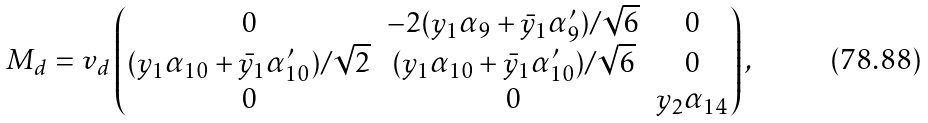Convert formula to latex. <formula><loc_0><loc_0><loc_500><loc_500>M _ { d } = v _ { d } \begin{pmatrix} 0 & - 2 ( y _ { 1 } \alpha _ { 9 } + \bar { y } _ { 1 } \alpha _ { 9 } ^ { \prime } ) / \sqrt { 6 } & 0 \\ ( y _ { 1 } \alpha _ { 1 0 } + \bar { y } _ { 1 } \alpha _ { 1 0 } ^ { \prime } ) / \sqrt { 2 } & ( y _ { 1 } \alpha _ { 1 0 } + \bar { y } _ { 1 } \alpha _ { 1 0 } ^ { \prime } ) / \sqrt { 6 } & 0 \\ 0 & 0 & y _ { 2 } \alpha _ { 1 4 } \end{pmatrix} ,</formula> 